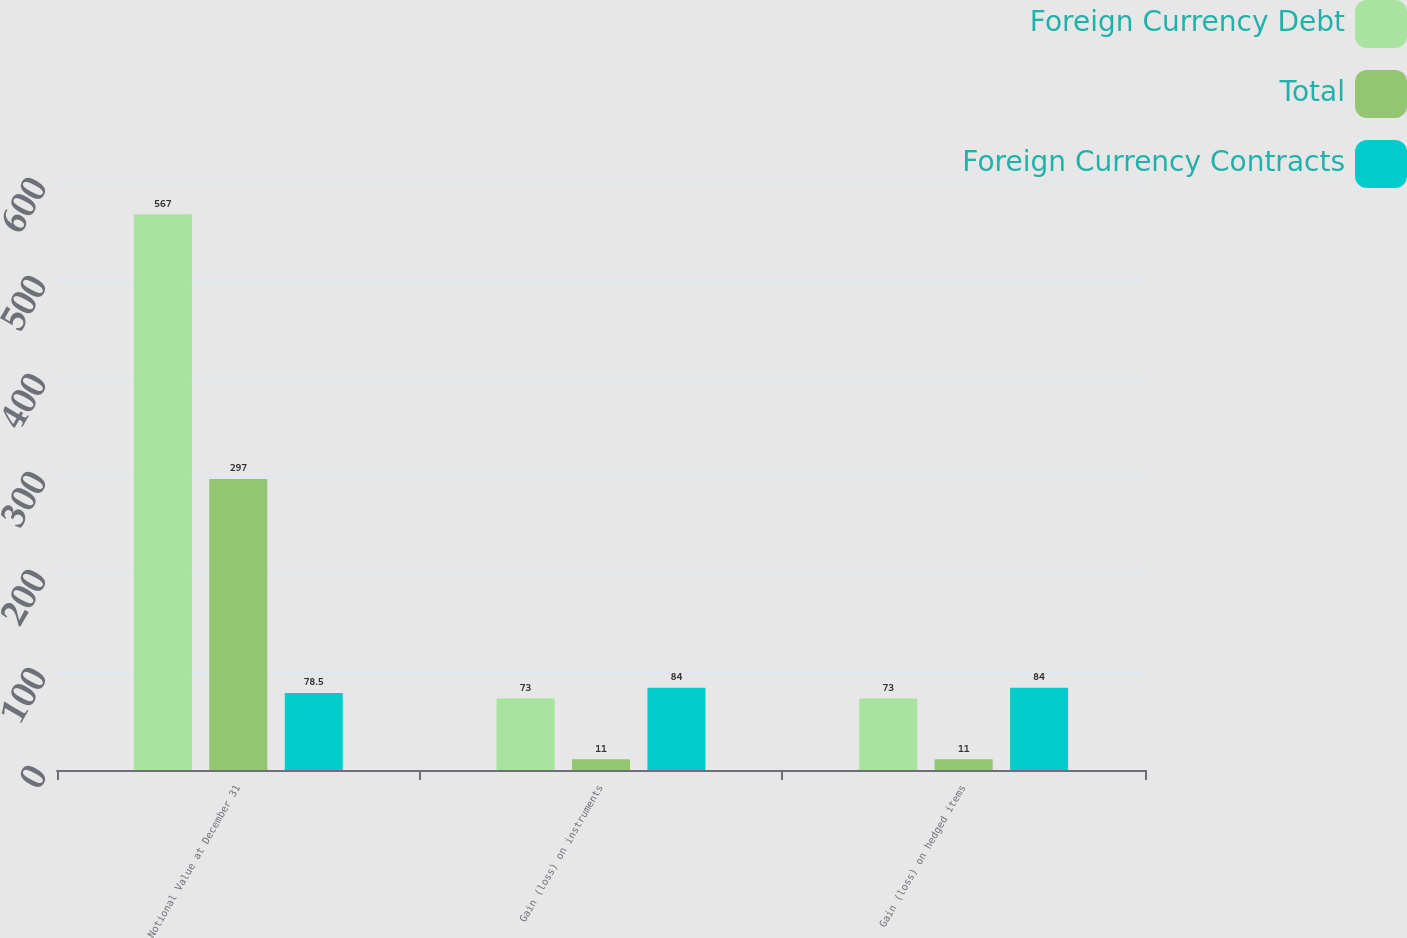Convert chart. <chart><loc_0><loc_0><loc_500><loc_500><stacked_bar_chart><ecel><fcel>Notional Value at December 31<fcel>Gain (loss) on instruments<fcel>Gain (loss) on hedged items<nl><fcel>Foreign Currency Debt<fcel>567<fcel>73<fcel>73<nl><fcel>Total<fcel>297<fcel>11<fcel>11<nl><fcel>Foreign Currency Contracts<fcel>78.5<fcel>84<fcel>84<nl></chart> 